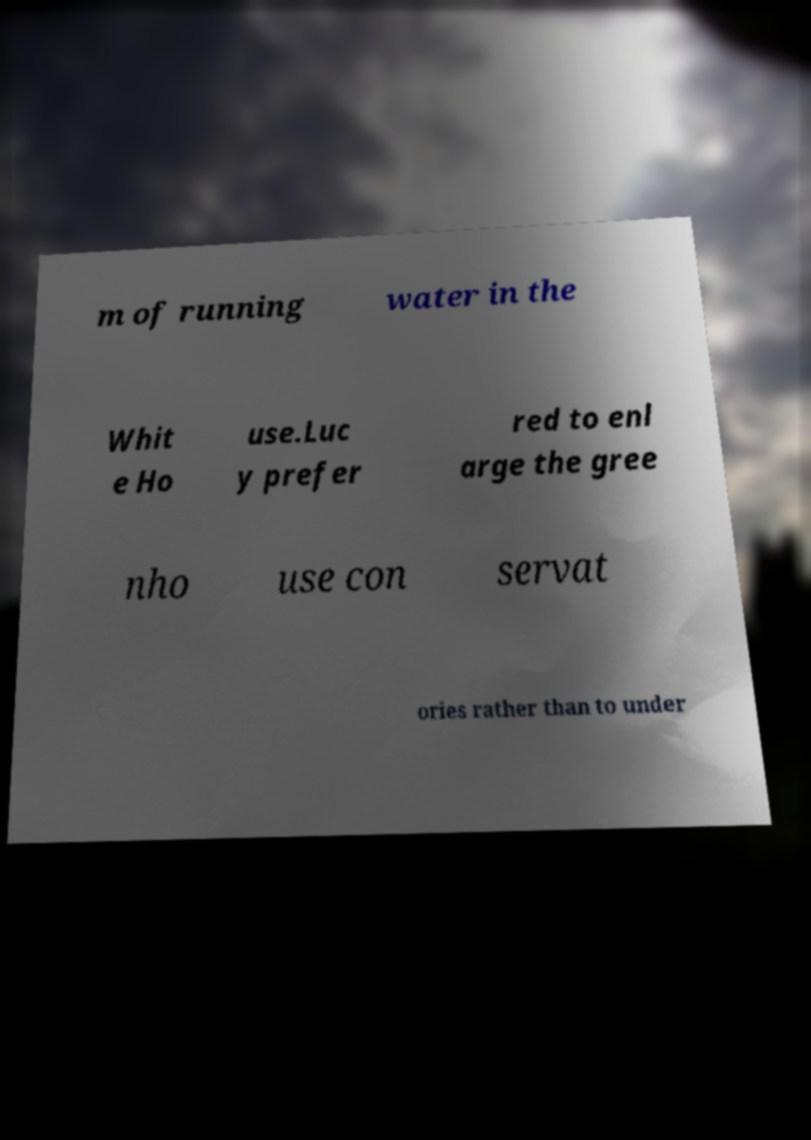Can you accurately transcribe the text from the provided image for me? m of running water in the Whit e Ho use.Luc y prefer red to enl arge the gree nho use con servat ories rather than to under 